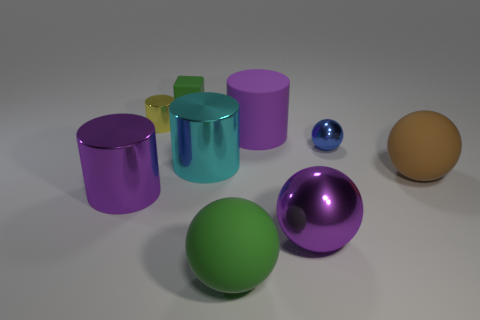There is a big rubber thing that is the same color as the tiny matte cube; what is its shape?
Provide a short and direct response. Sphere. There is another cylinder that is the same color as the large rubber cylinder; what size is it?
Offer a terse response. Large. Do the rubber cylinder and the rubber cube have the same color?
Provide a succinct answer. No. Do the large metallic cylinder to the left of the tiny yellow shiny object and the small block have the same color?
Your response must be concise. No. What number of brown rubber balls are in front of the purple sphere?
Keep it short and to the point. 0. Are there more small gray metallic spheres than big metal balls?
Offer a terse response. No. The rubber thing that is to the right of the big cyan metal cylinder and behind the tiny blue metallic object has what shape?
Your answer should be compact. Cylinder. Is there a yellow thing?
Provide a succinct answer. Yes. There is a big brown thing that is the same shape as the blue object; what is it made of?
Offer a terse response. Rubber. There is a large purple shiny thing on the left side of the big rubber object that is in front of the large purple metal sphere to the left of the small blue metallic sphere; what shape is it?
Your answer should be very brief. Cylinder. 